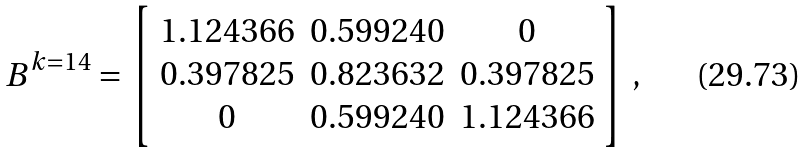Convert formula to latex. <formula><loc_0><loc_0><loc_500><loc_500>B ^ { k = 1 4 } = \left [ \begin{array} { c c c } 1 . 1 2 4 3 6 6 & 0 . 5 9 9 2 4 0 & 0 \\ 0 . 3 9 7 8 2 5 & 0 . 8 2 3 6 3 2 & 0 . 3 9 7 8 2 5 \\ 0 & 0 . 5 9 9 2 4 0 & 1 . 1 2 4 3 6 6 \\ \end{array} \right ] \, ,</formula> 